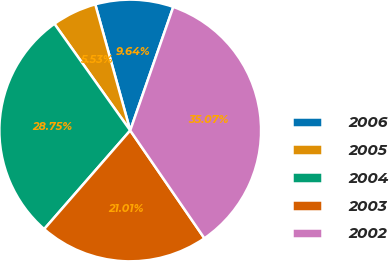Convert chart to OTSL. <chart><loc_0><loc_0><loc_500><loc_500><pie_chart><fcel>2006<fcel>2005<fcel>2004<fcel>2003<fcel>2002<nl><fcel>9.64%<fcel>5.53%<fcel>28.75%<fcel>21.01%<fcel>35.07%<nl></chart> 